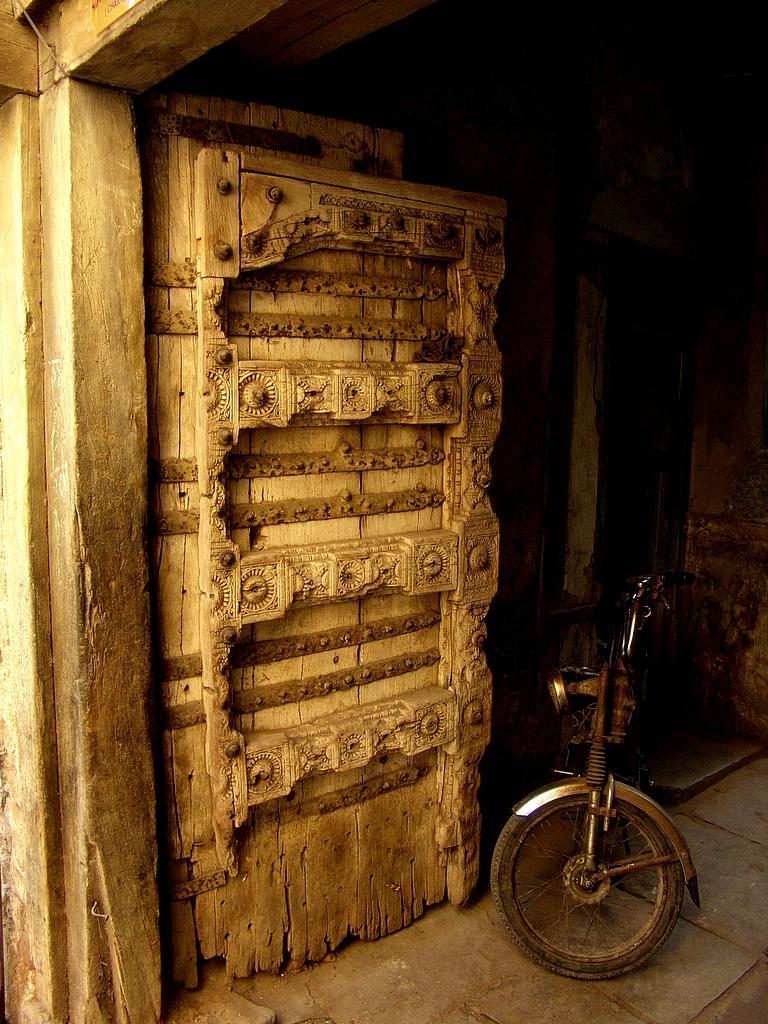In one or two sentences, can you explain what this image depicts? In this image we can see there is a wooden door, beside this door there is a vehicle parked on the floor. 